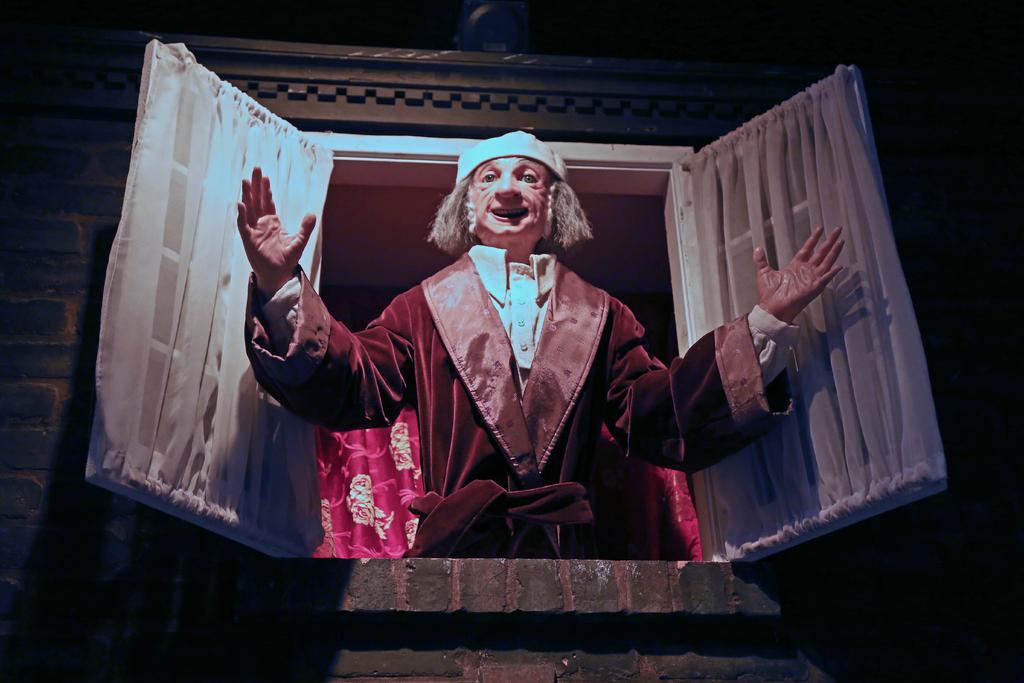Can you describe this image briefly? This image consists of a person in the middle. This looks like a window. 